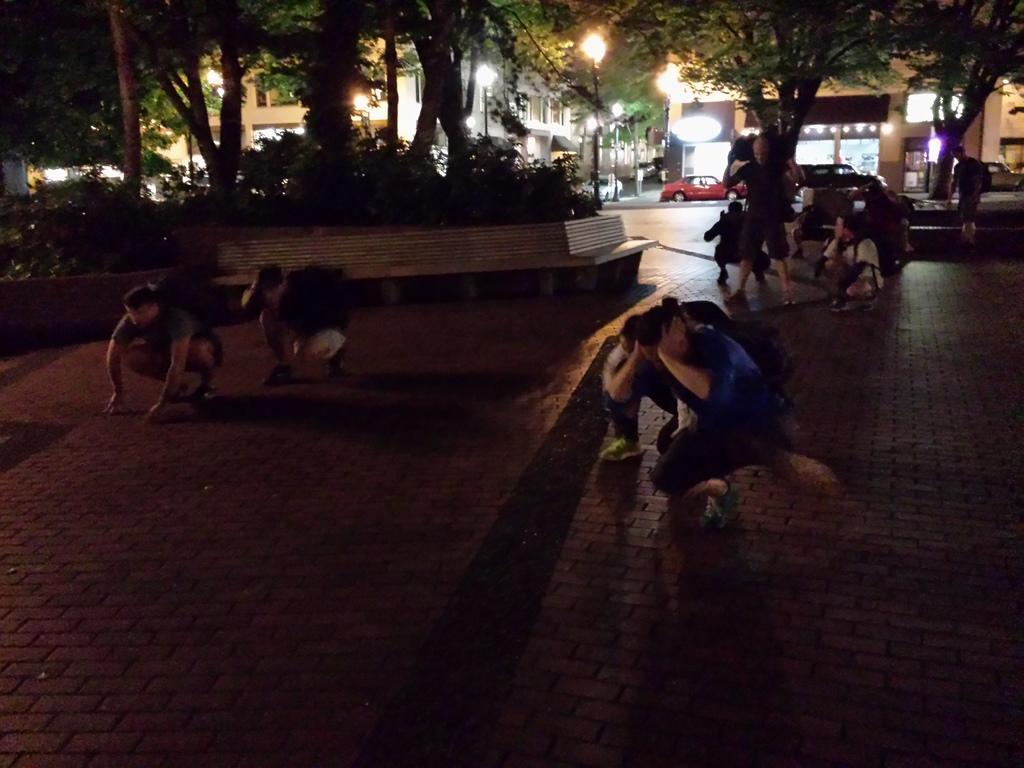What are the people in the image doing? The people in the image are sitting on the ground. What type of natural environment is present in the image? There are a lot of trees in the image. What can be seen in the background of the image? There are buildings visible in the background of the image. What type of transportation is parked in the image? Cars are parked on the road in the image. How many toys can be seen on the ground in the image? There are no toys present in the image. What type of snakes can be seen slithering through the trees in the image? There are no snakes present in the image; it features people sitting on the ground and trees in the background. 